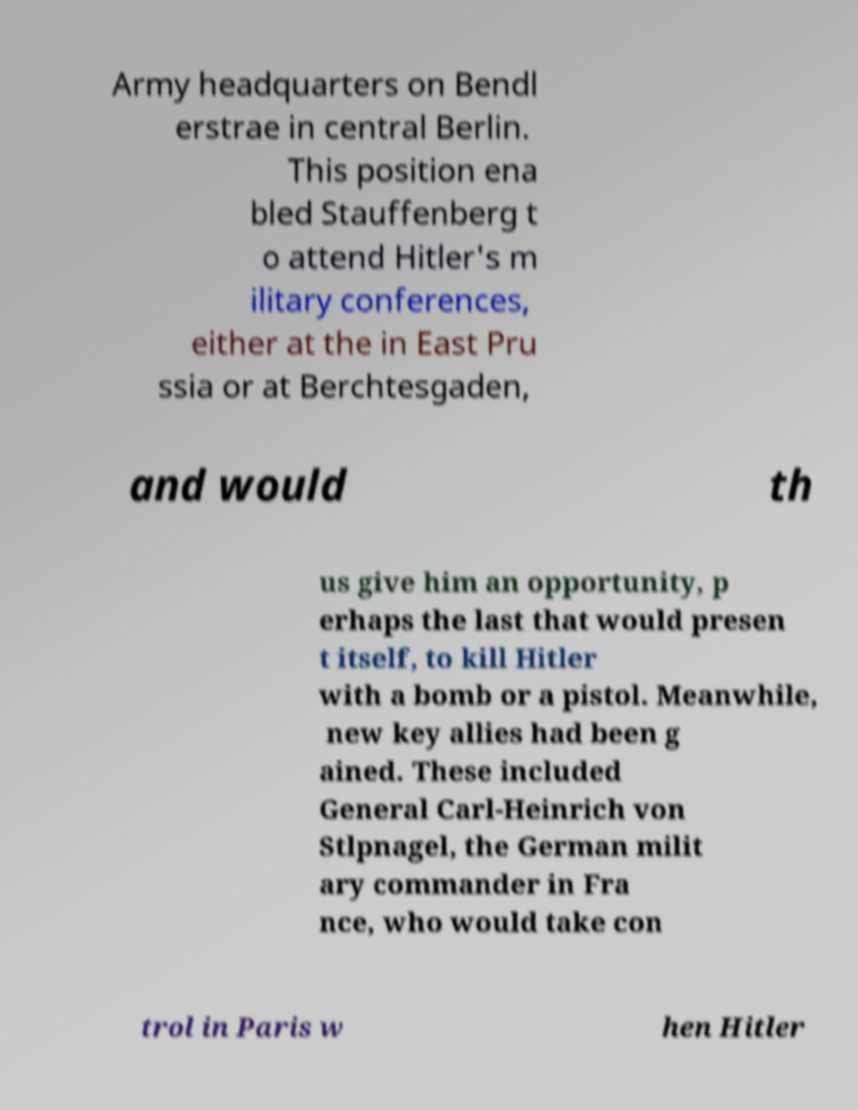Please read and relay the text visible in this image. What does it say? Army headquarters on Bendl erstrae in central Berlin. This position ena bled Stauffenberg t o attend Hitler's m ilitary conferences, either at the in East Pru ssia or at Berchtesgaden, and would th us give him an opportunity, p erhaps the last that would presen t itself, to kill Hitler with a bomb or a pistol. Meanwhile, new key allies had been g ained. These included General Carl-Heinrich von Stlpnagel, the German milit ary commander in Fra nce, who would take con trol in Paris w hen Hitler 